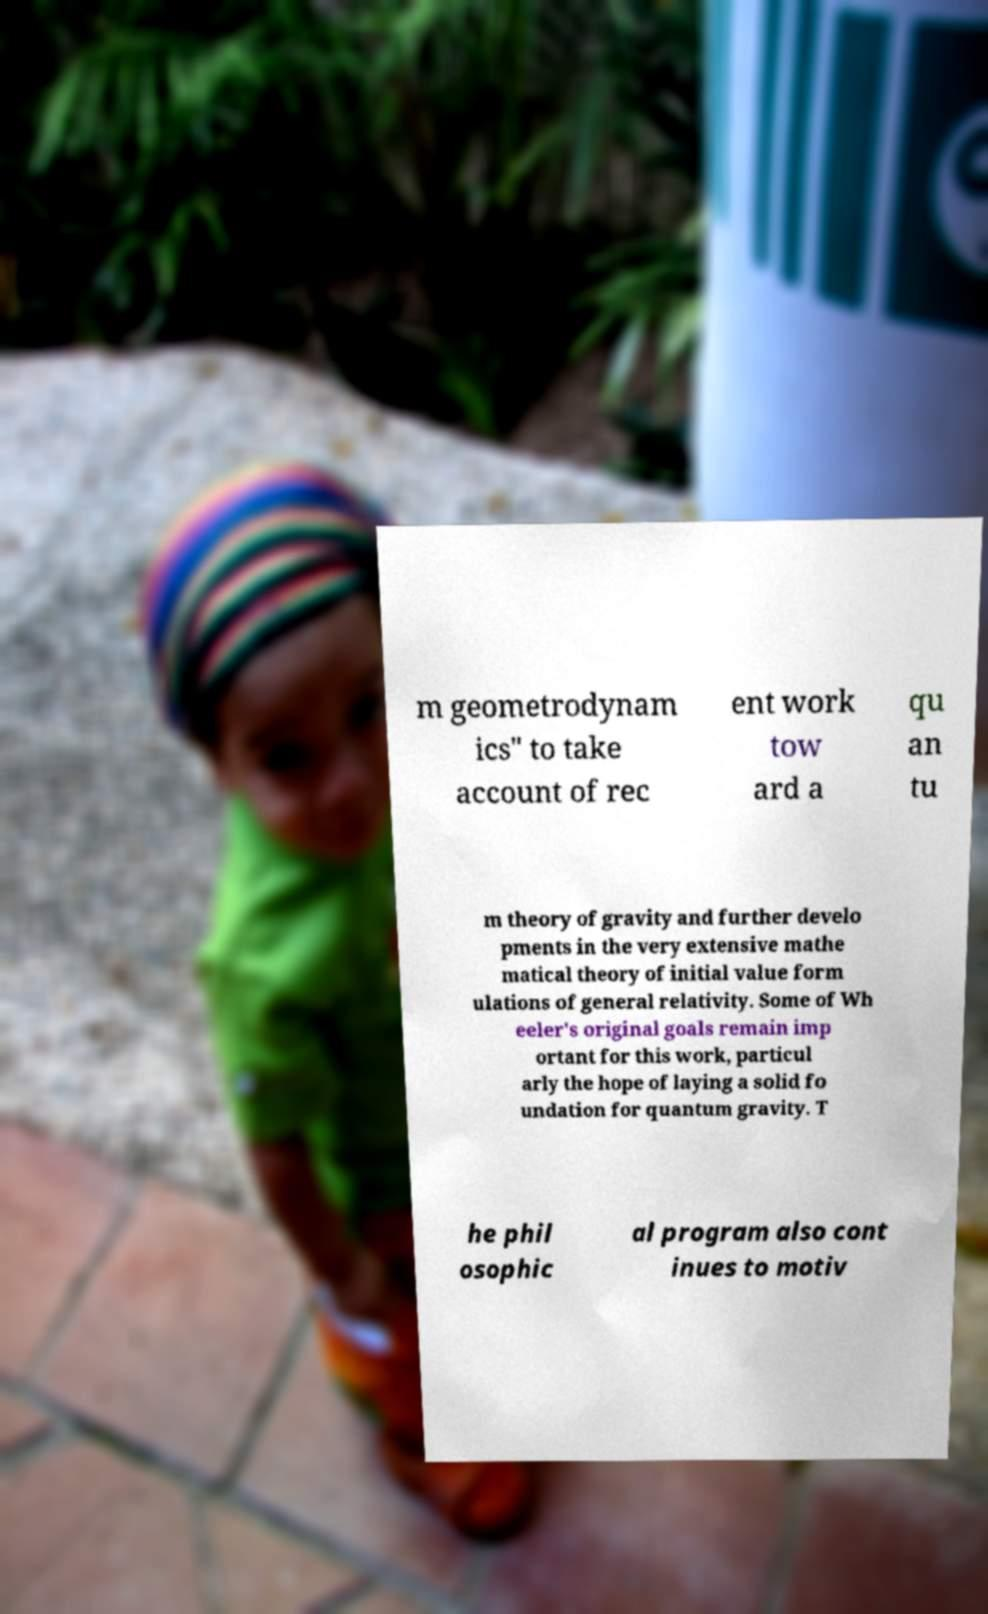Could you assist in decoding the text presented in this image and type it out clearly? m geometrodynam ics" to take account of rec ent work tow ard a qu an tu m theory of gravity and further develo pments in the very extensive mathe matical theory of initial value form ulations of general relativity. Some of Wh eeler's original goals remain imp ortant for this work, particul arly the hope of laying a solid fo undation for quantum gravity. T he phil osophic al program also cont inues to motiv 